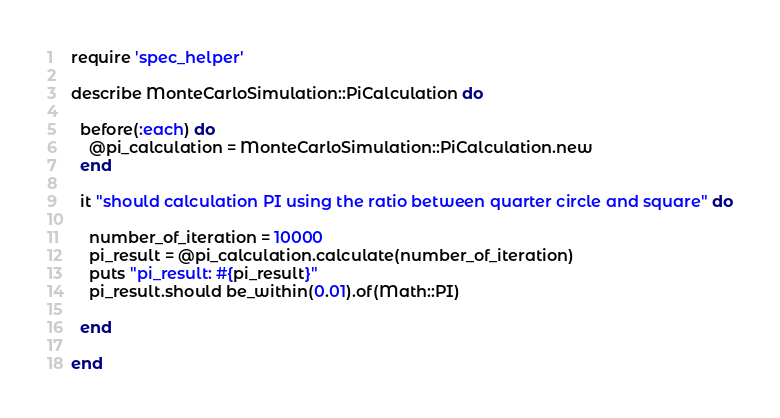<code> <loc_0><loc_0><loc_500><loc_500><_Ruby_>require 'spec_helper'

describe MonteCarloSimulation::PiCalculation do

  before(:each) do
    @pi_calculation = MonteCarloSimulation::PiCalculation.new
  end

  it "should calculation PI using the ratio between quarter circle and square" do

    number_of_iteration = 10000
    pi_result = @pi_calculation.calculate(number_of_iteration)
    puts "pi_result: #{pi_result}"
    pi_result.should be_within(0.01).of(Math::PI)

  end

end
</code> 